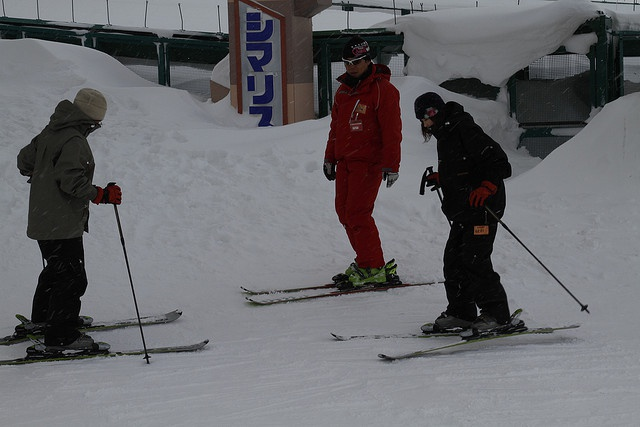Describe the objects in this image and their specific colors. I can see people in gray and black tones, people in gray, black, and maroon tones, people in gray, black, maroon, and darkgray tones, skis in gray and black tones, and skis in gray and black tones in this image. 